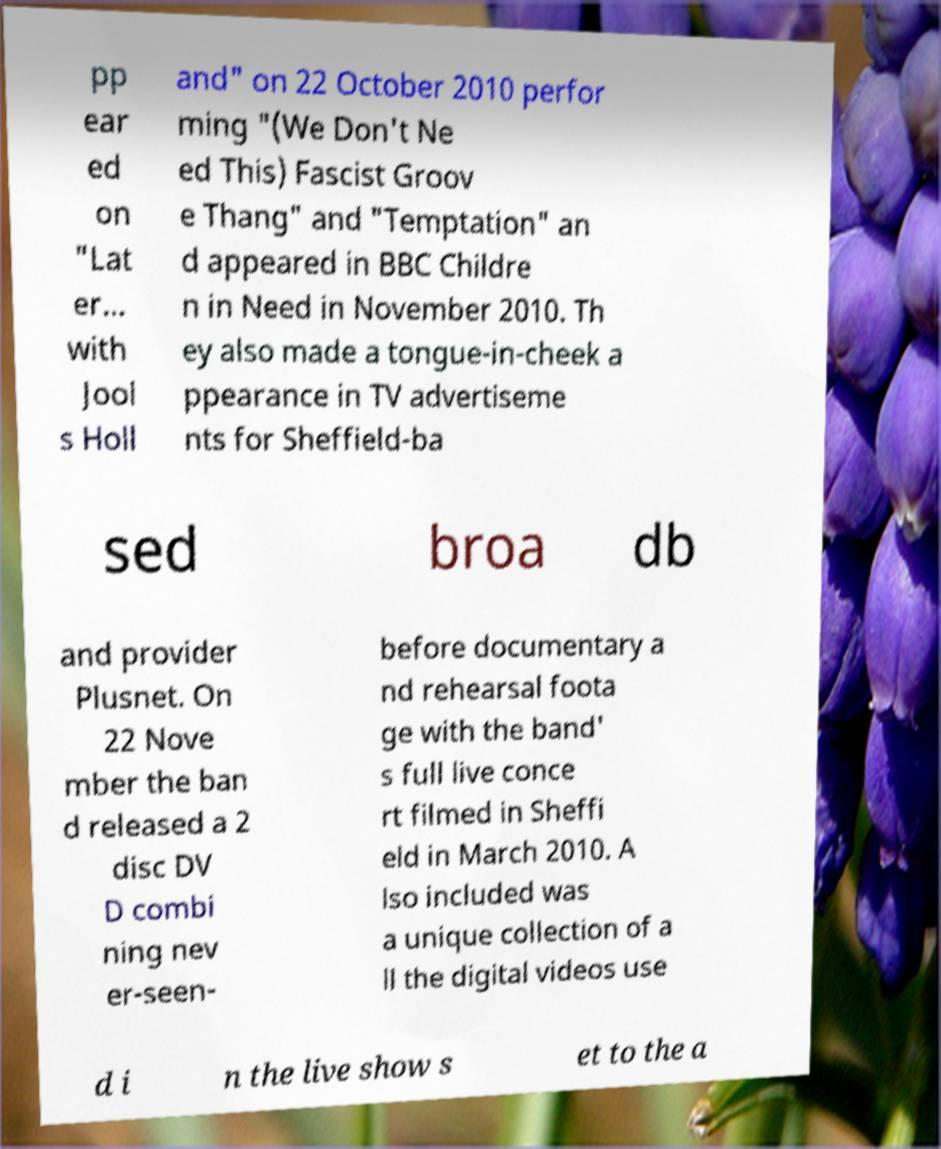For documentation purposes, I need the text within this image transcribed. Could you provide that? pp ear ed on "Lat er... with Jool s Holl and" on 22 October 2010 perfor ming "(We Don't Ne ed This) Fascist Groov e Thang" and "Temptation" an d appeared in BBC Childre n in Need in November 2010. Th ey also made a tongue-in-cheek a ppearance in TV advertiseme nts for Sheffield-ba sed broa db and provider Plusnet. On 22 Nove mber the ban d released a 2 disc DV D combi ning nev er-seen- before documentary a nd rehearsal foota ge with the band' s full live conce rt filmed in Sheffi eld in March 2010. A lso included was a unique collection of a ll the digital videos use d i n the live show s et to the a 